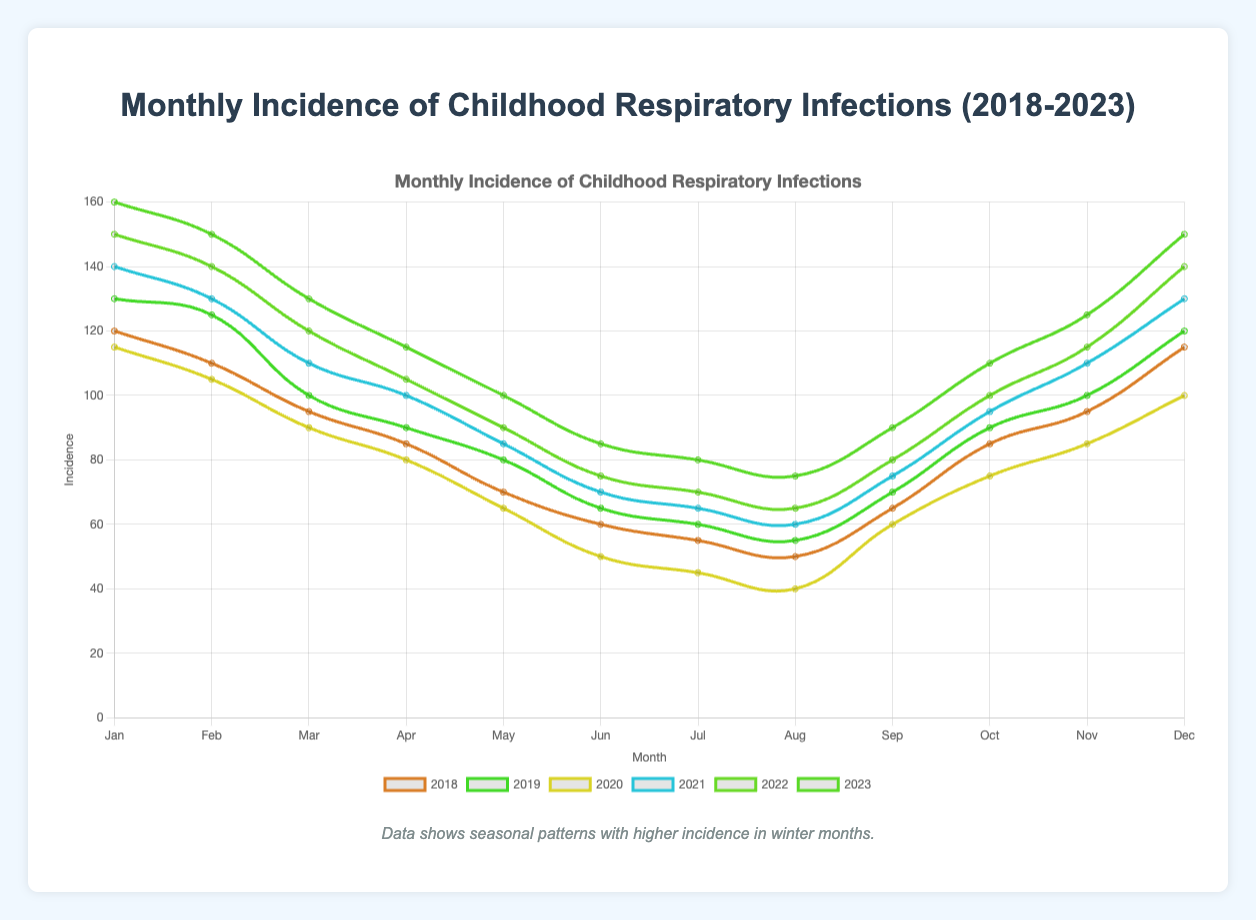What's the trend of respiratory infection incidences during winter over the past five years? By observing the winter months (December, January, February) for each year on the plot, we can see that the incidence rates generally increase. From 2018 to 2023, the incidences in January show an increasing trend, from 120 in 2018 to 160 in 2023.
Answer: Increasing trend Which season has the highest incidence of respiratory infections in 2021? By examining the lines representing each year's incidences across different months, it is evident that winter months (January, February, December) have higher peaks compared to other seasons. In 2021, January (140), February (130), and December (130) are notably high.
Answer: Winter Which year shows the lowest incidence rate during the summer months? Summer months include June, July, and August. To determine the lowest year, observe and compare the lowest points for these three months across all years. The year 2020 shows the lowest, with values 50, 45, and 40 for June, July, and August respectively.
Answer: 2020 What's the difference in respiratory infection incidence between January 2022 and July 2022? Look at the points corresponding to January and July 2022. January shows an incidence of 150, and July shows an incidence of 70. The difference is 150 - 70 = 80.
Answer: 80 What is the average incidence of respiratory infections in April from 2018 to 2023? Collect the data points for April across all years: 2018 (85), 2019 (90), 2020 (80), 2021 (100), 2022 (105), and 2023 (115). The sum is 575, and there are 6 data points. The average is 575 / 6 ≈ 95.8.
Answer: 95.8 Compare the incidence of respiratory infections in November 2020 and November 2023. On the plot, November 2020 shows an incidence of 85 and November 2023 shows an incidence of 125. 125 is greater than 85.
Answer: 2023 has higher incidence What is the most notable seasonal trend observed in the data? The plot demonstrates that winter months consistently show the highest incidence of respiratory infections each year. This pattern indicates a marked seasonal trend with winter witnessing more cases.
Answer: Winter has the highest incidence What's the highest incidence rate recorded in the plotted data, and in which month and year did it occur? By identifying the peak point across the entire plot, we find January 2023 has the highest incidence rate of 160.
Answer: January 2023, 160 Are there any months where the incidence of respiratory infections stayed relatively constant over the five years? Check each month across different years for relatively constant values. August shows a relatively less fluctuating pattern with values around 50-75 in 2018 to 2023 (50, 55, 40, 60, 65, 75).
Answer: August How does the incidence in September 2023 compare to that in September 2022? September 2023 shows an incidence of 90, and September 2022 shows an incidence of 80 according to the plot. 90 is greater than 80.
Answer: September 2023 is higher 